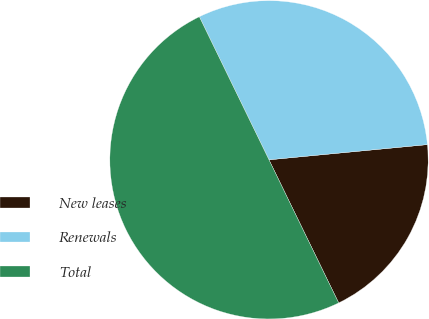Convert chart to OTSL. <chart><loc_0><loc_0><loc_500><loc_500><pie_chart><fcel>New leases<fcel>Renewals<fcel>Total<nl><fcel>19.31%<fcel>30.69%<fcel>50.0%<nl></chart> 